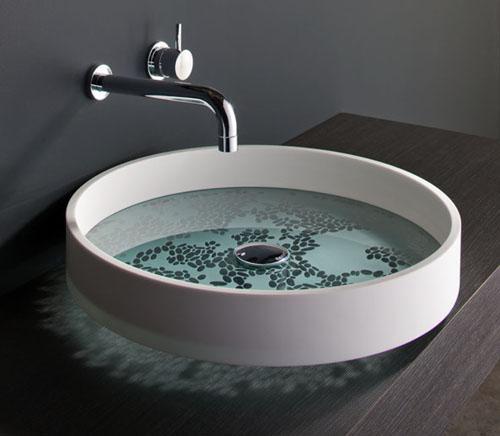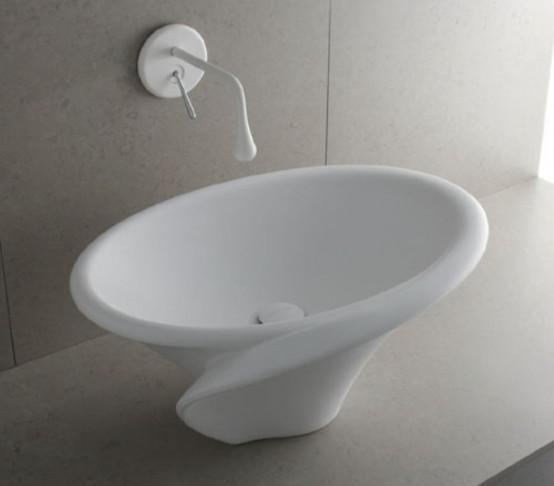The first image is the image on the left, the second image is the image on the right. Assess this claim about the two images: "The sink on the right has a somewhat spiral shape and has a spout mounted on the wall above it, and the counter-top sink on the left is white and rounded with a silver spout over the basin.". Correct or not? Answer yes or no. Yes. The first image is the image on the left, the second image is the image on the right. Evaluate the accuracy of this statement regarding the images: "One wash basin currently contains water.". Is it true? Answer yes or no. Yes. 